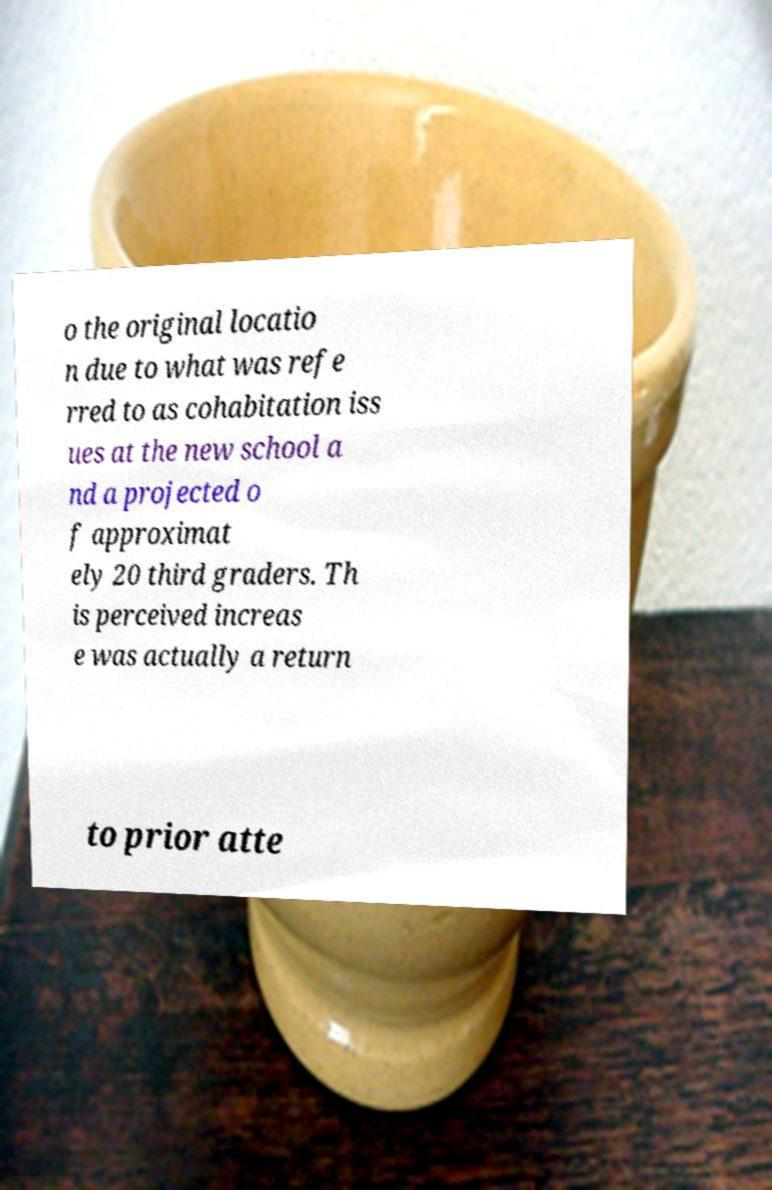For documentation purposes, I need the text within this image transcribed. Could you provide that? o the original locatio n due to what was refe rred to as cohabitation iss ues at the new school a nd a projected o f approximat ely 20 third graders. Th is perceived increas e was actually a return to prior atte 